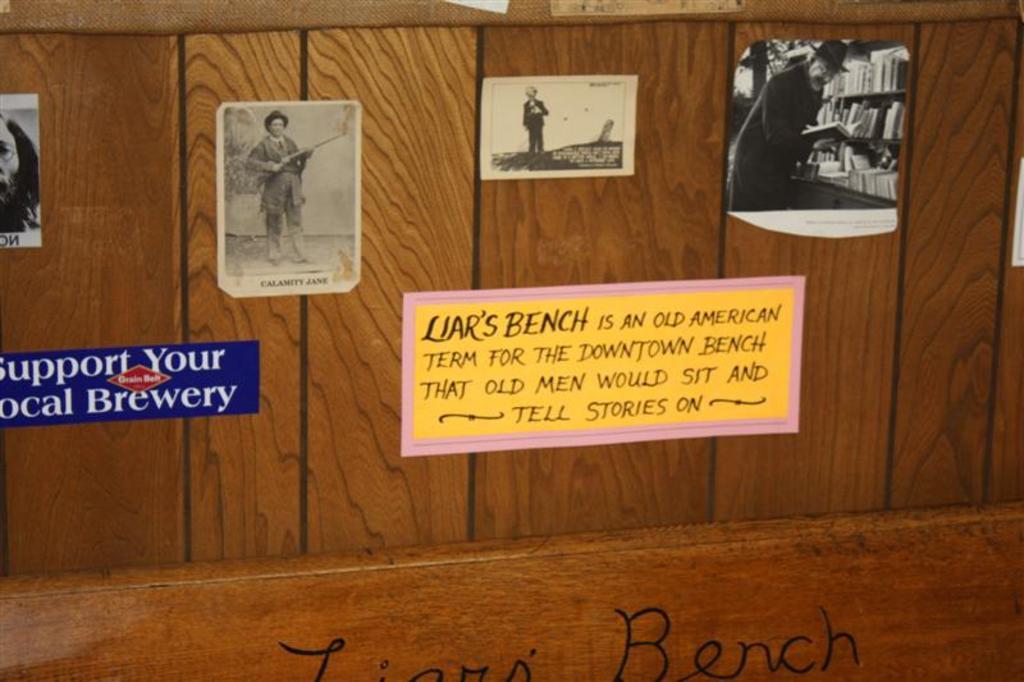Whose bench is shown in the image?
Provide a short and direct response. Liar's. Who should you support?
Make the answer very short. Local brewery. 